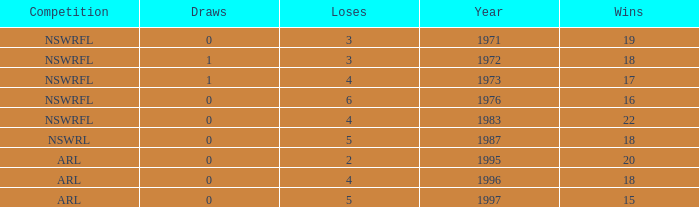What sum of Losses has Year greater than 1972, and Competition of nswrfl, and Draws 0, and Wins 16? 6.0. 